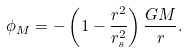<formula> <loc_0><loc_0><loc_500><loc_500>\phi _ { M } = - \left ( 1 - \frac { r ^ { 2 } } { r _ { s } ^ { 2 } } \right ) \frac { G M } { r } .</formula> 